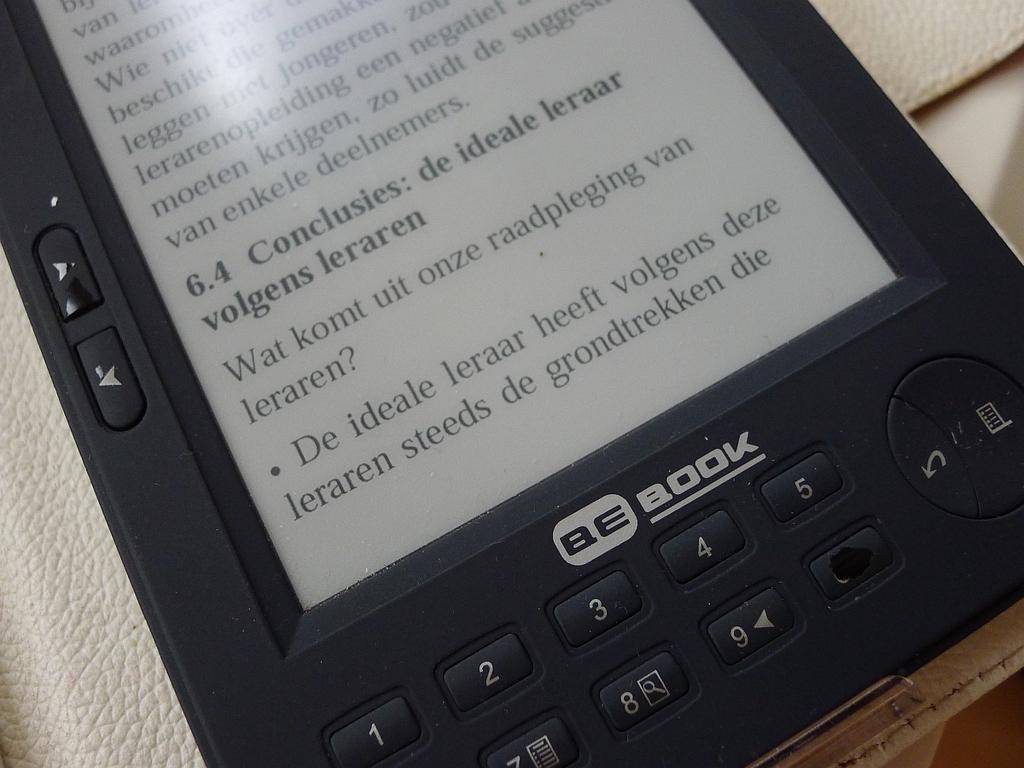What kind of ebook is that?
Provide a succinct answer. Be book. What is the title of 6.4?
Your answer should be very brief. Conclusies: de ideale leraar volgens leraren. 